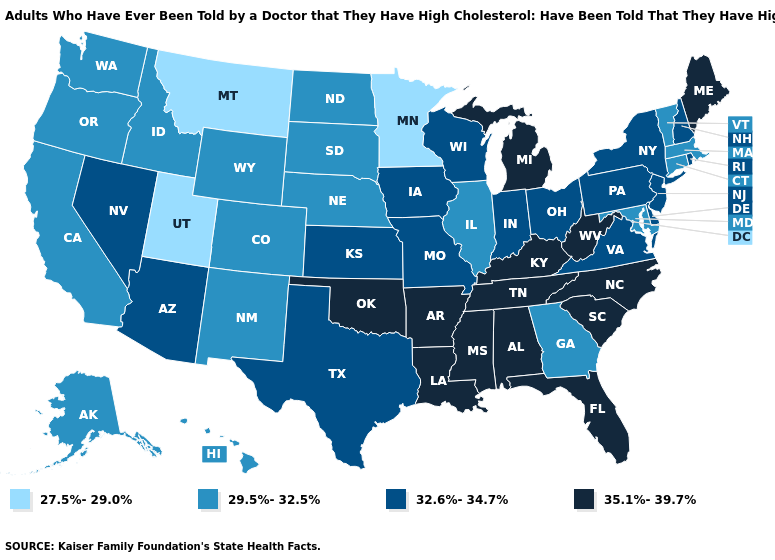Name the states that have a value in the range 32.6%-34.7%?
Be succinct. Arizona, Delaware, Indiana, Iowa, Kansas, Missouri, Nevada, New Hampshire, New Jersey, New York, Ohio, Pennsylvania, Rhode Island, Texas, Virginia, Wisconsin. Does Minnesota have the lowest value in the USA?
Give a very brief answer. Yes. Name the states that have a value in the range 29.5%-32.5%?
Write a very short answer. Alaska, California, Colorado, Connecticut, Georgia, Hawaii, Idaho, Illinois, Maryland, Massachusetts, Nebraska, New Mexico, North Dakota, Oregon, South Dakota, Vermont, Washington, Wyoming. What is the lowest value in the USA?
Concise answer only. 27.5%-29.0%. What is the value of Minnesota?
Write a very short answer. 27.5%-29.0%. What is the highest value in the West ?
Answer briefly. 32.6%-34.7%. Does Arizona have a lower value than Texas?
Give a very brief answer. No. What is the lowest value in the USA?
Quick response, please. 27.5%-29.0%. What is the value of North Dakota?
Answer briefly. 29.5%-32.5%. Does Arizona have a lower value than Tennessee?
Write a very short answer. Yes. What is the lowest value in the Northeast?
Concise answer only. 29.5%-32.5%. What is the lowest value in the USA?
Be succinct. 27.5%-29.0%. What is the value of Alaska?
Short answer required. 29.5%-32.5%. Name the states that have a value in the range 27.5%-29.0%?
Concise answer only. Minnesota, Montana, Utah. Which states have the highest value in the USA?
Short answer required. Alabama, Arkansas, Florida, Kentucky, Louisiana, Maine, Michigan, Mississippi, North Carolina, Oklahoma, South Carolina, Tennessee, West Virginia. 